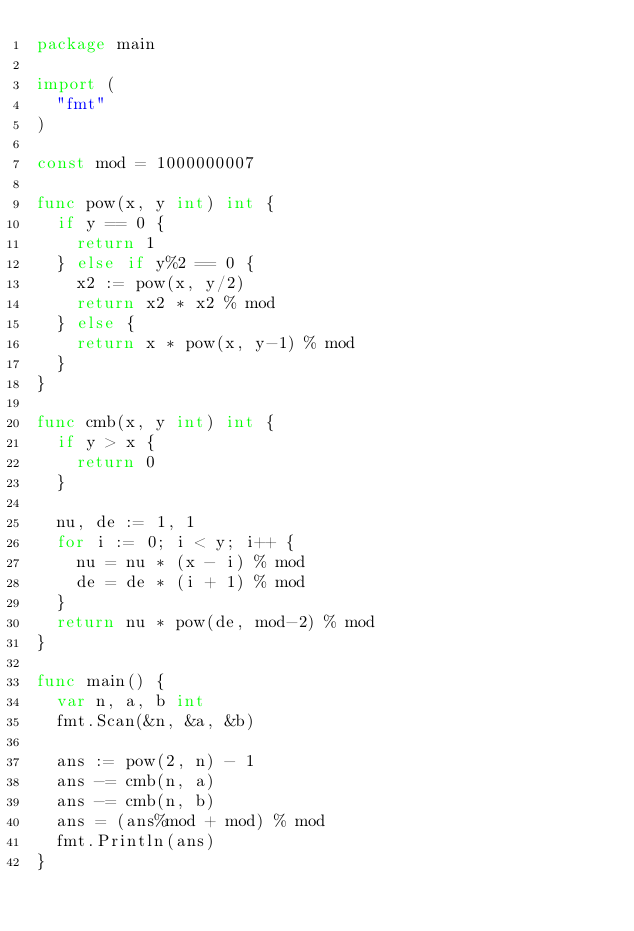Convert code to text. <code><loc_0><loc_0><loc_500><loc_500><_Go_>package main

import (
	"fmt"
)

const mod = 1000000007

func pow(x, y int) int {
	if y == 0 {
		return 1
	} else if y%2 == 0 {
		x2 := pow(x, y/2)
		return x2 * x2 % mod
	} else {
		return x * pow(x, y-1) % mod
	}
}

func cmb(x, y int) int {
	if y > x {
		return 0
	}

	nu, de := 1, 1
	for i := 0; i < y; i++ {
		nu = nu * (x - i) % mod
		de = de * (i + 1) % mod
	}
	return nu * pow(de, mod-2) % mod
}

func main() {
	var n, a, b int
	fmt.Scan(&n, &a, &b)

	ans := pow(2, n) - 1
	ans -= cmb(n, a)
	ans -= cmb(n, b)
	ans = (ans%mod + mod) % mod
	fmt.Println(ans)
}
</code> 